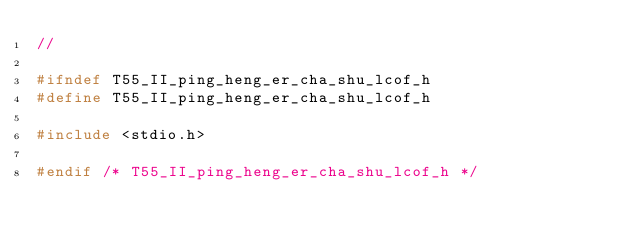Convert code to text. <code><loc_0><loc_0><loc_500><loc_500><_C_>//

#ifndef T55_II_ping_heng_er_cha_shu_lcof_h
#define T55_II_ping_heng_er_cha_shu_lcof_h

#include <stdio.h>

#endif /* T55_II_ping_heng_er_cha_shu_lcof_h */
</code> 